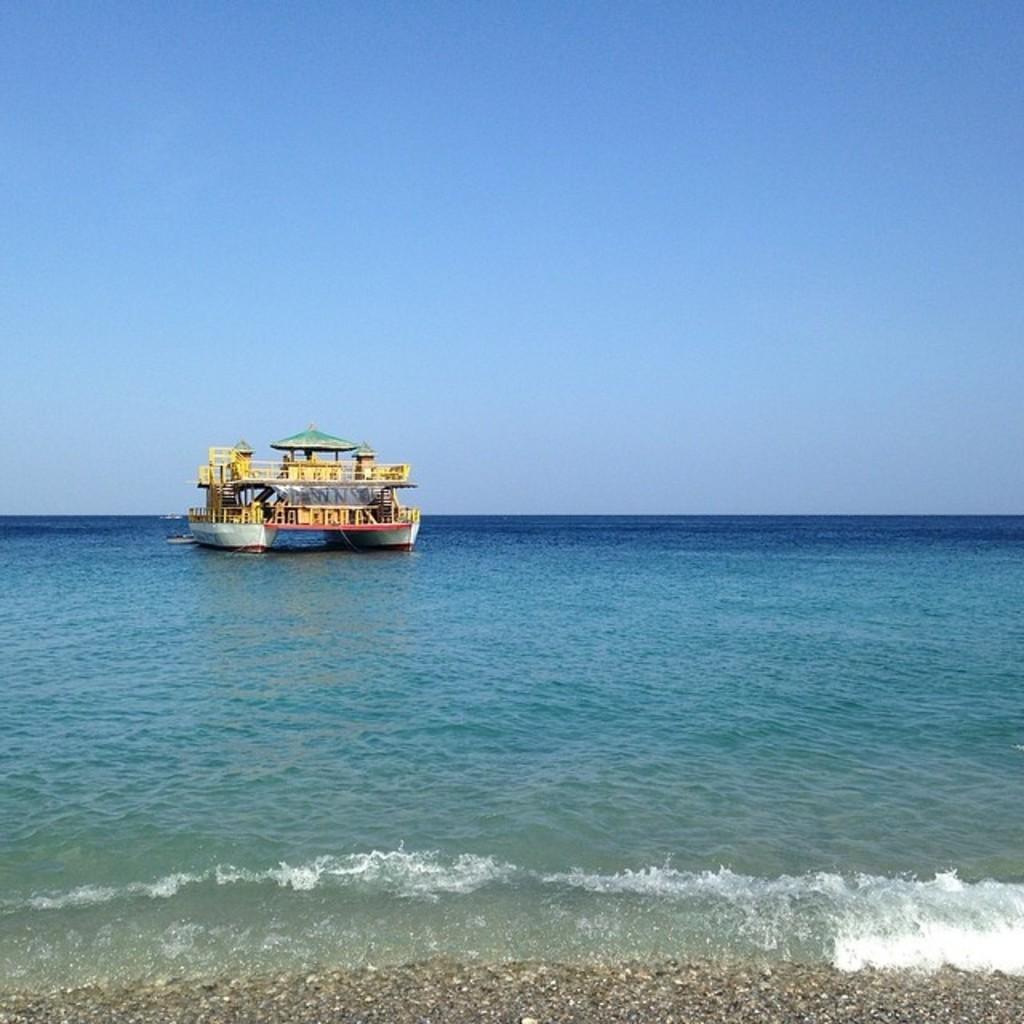In one or two sentences, can you explain what this image depicts? In this image there is a boat sailing on the water having tides. Bottom of the image there is land. Top of the image there is sky. 